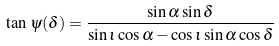Convert formula to latex. <formula><loc_0><loc_0><loc_500><loc_500>\tan \, \psi ( \delta ) = \frac { \sin \alpha \sin \delta } { \sin \iota \cos \alpha - \cos \iota \sin \alpha \cos \delta }</formula> 